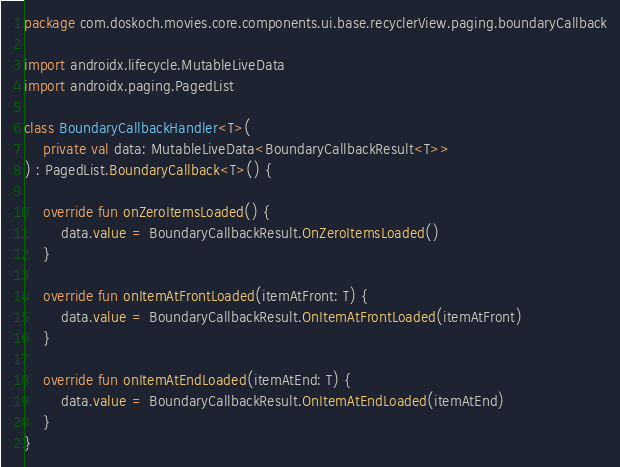Convert code to text. <code><loc_0><loc_0><loc_500><loc_500><_Kotlin_>package com.doskoch.movies.core.components.ui.base.recyclerView.paging.boundaryCallback

import androidx.lifecycle.MutableLiveData
import androidx.paging.PagedList

class BoundaryCallbackHandler<T>(
    private val data: MutableLiveData<BoundaryCallbackResult<T>>
) : PagedList.BoundaryCallback<T>() {

    override fun onZeroItemsLoaded() {
        data.value = BoundaryCallbackResult.OnZeroItemsLoaded()
    }

    override fun onItemAtFrontLoaded(itemAtFront: T) {
        data.value = BoundaryCallbackResult.OnItemAtFrontLoaded(itemAtFront)
    }

    override fun onItemAtEndLoaded(itemAtEnd: T) {
        data.value = BoundaryCallbackResult.OnItemAtEndLoaded(itemAtEnd)
    }
}</code> 